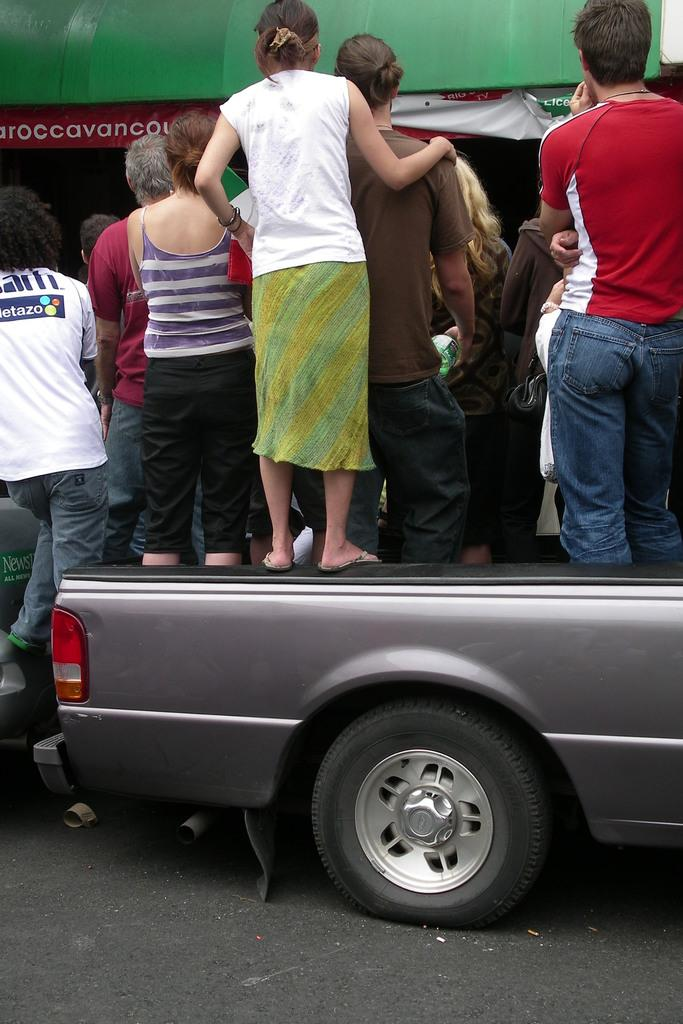How many people are in the group in the image? The number of people in the group cannot be determined from the provided facts. What are the people in the group doing? The people in the group are standing together. What is the color of the vehicle they are standing on? The vehicle is grey in color. What color can be seen in the background of the image? There is a green color shade in the background of the image. What type of vegetable is being used as a sponge by the people in the image? There is no vegetable or sponge present in the image; the people are simply standing together on a grey vehicle. 